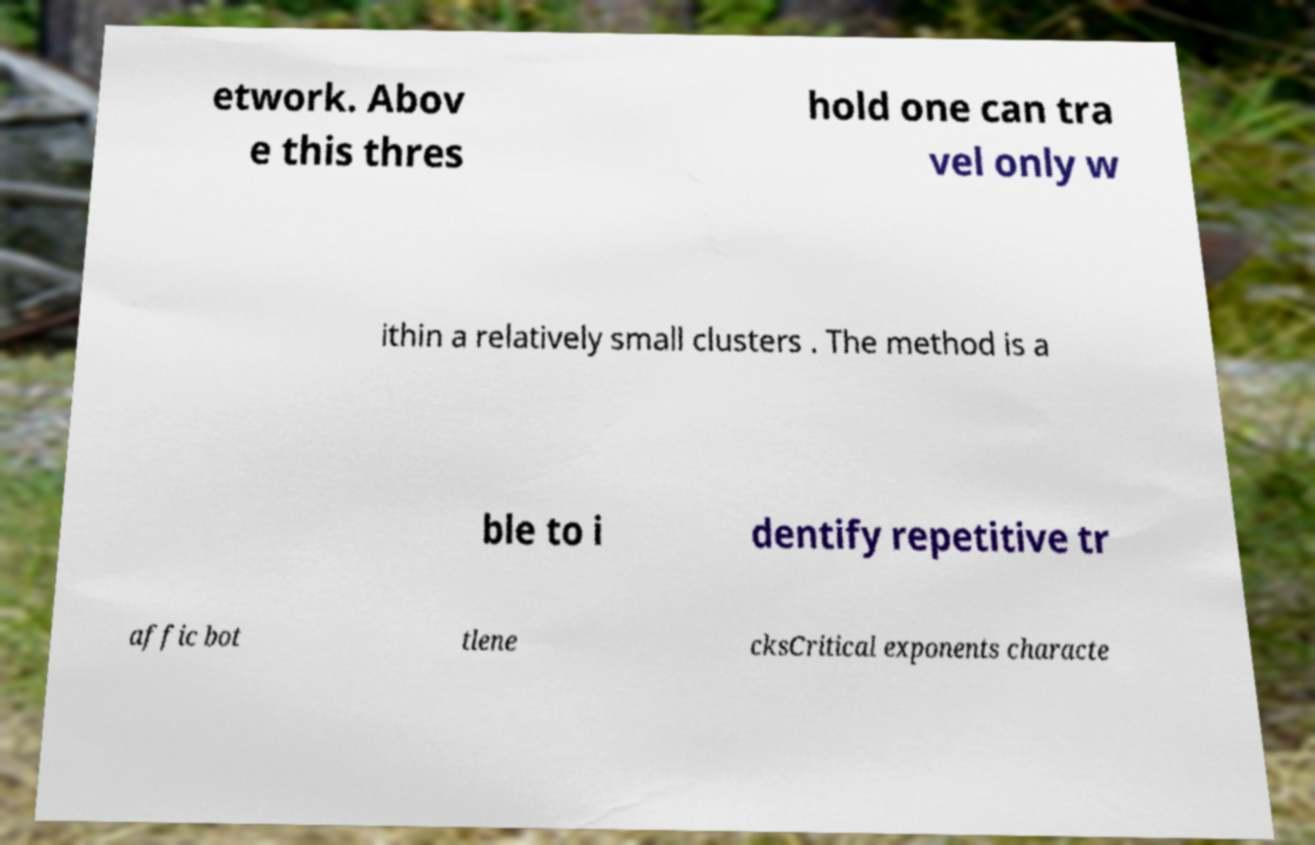For documentation purposes, I need the text within this image transcribed. Could you provide that? etwork. Abov e this thres hold one can tra vel only w ithin a relatively small clusters . The method is a ble to i dentify repetitive tr affic bot tlene cksCritical exponents characte 